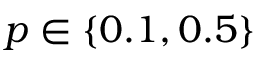Convert formula to latex. <formula><loc_0><loc_0><loc_500><loc_500>p \in \{ 0 . 1 , 0 . 5 \}</formula> 